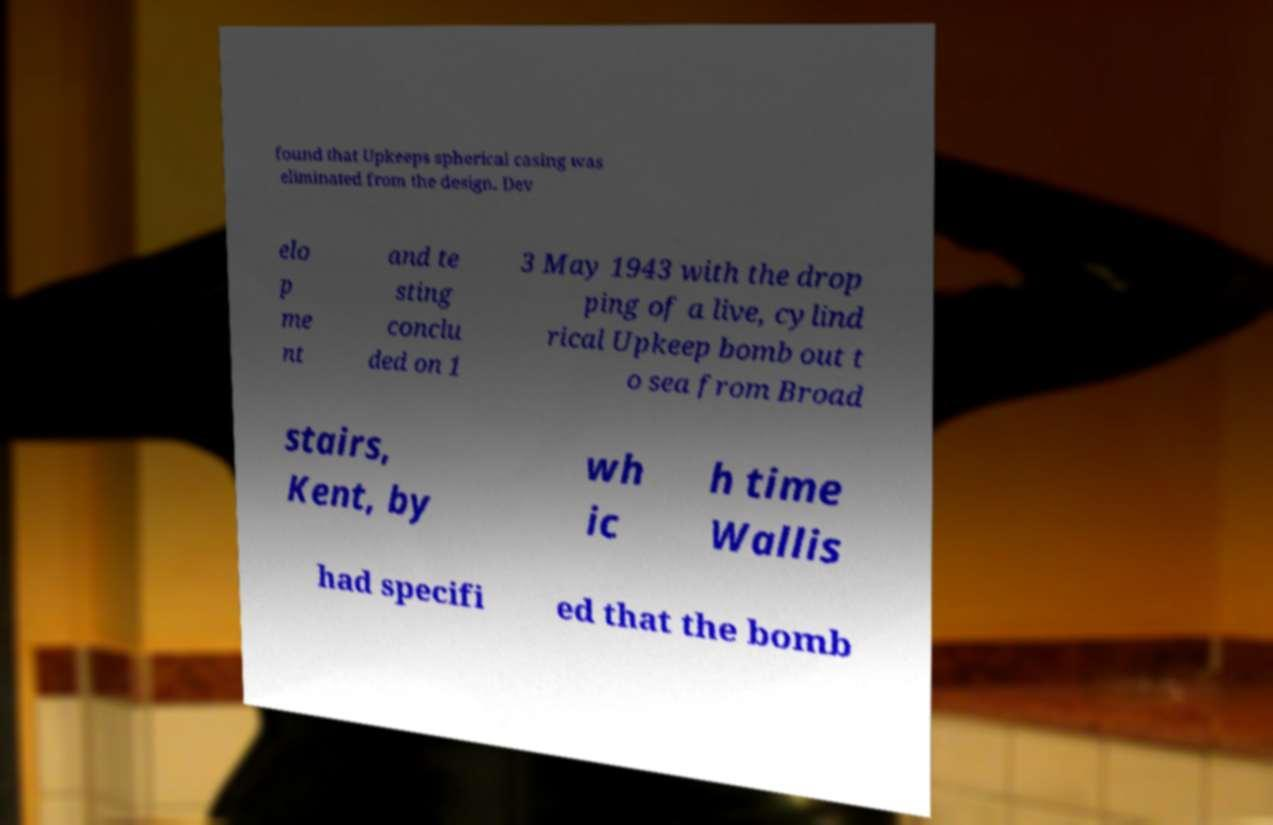For documentation purposes, I need the text within this image transcribed. Could you provide that? found that Upkeeps spherical casing was eliminated from the design. Dev elo p me nt and te sting conclu ded on 1 3 May 1943 with the drop ping of a live, cylind rical Upkeep bomb out t o sea from Broad stairs, Kent, by wh ic h time Wallis had specifi ed that the bomb 